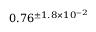Convert formula to latex. <formula><loc_0><loc_0><loc_500><loc_500>0 . 7 6 ^ { \pm 1 . 8 \times 1 0 ^ { - 2 } }</formula> 